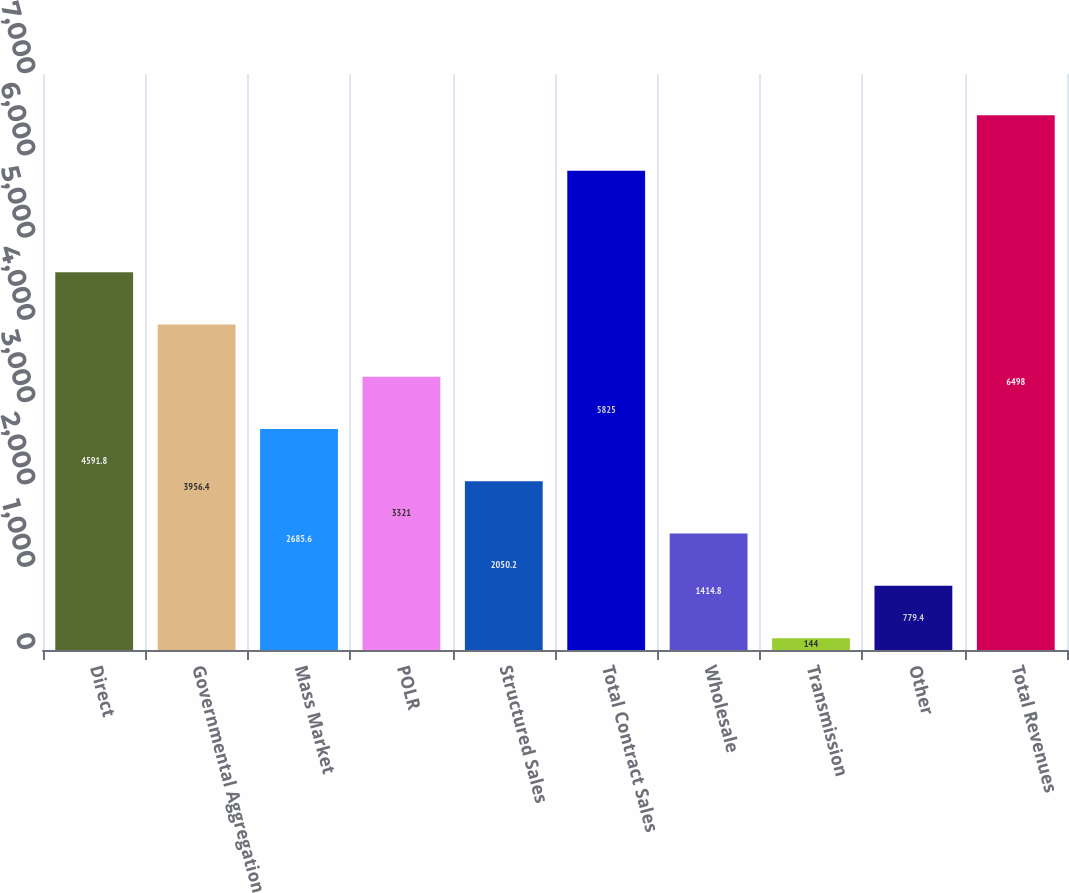Convert chart to OTSL. <chart><loc_0><loc_0><loc_500><loc_500><bar_chart><fcel>Direct<fcel>Governmental Aggregation<fcel>Mass Market<fcel>POLR<fcel>Structured Sales<fcel>Total Contract Sales<fcel>Wholesale<fcel>Transmission<fcel>Other<fcel>Total Revenues<nl><fcel>4591.8<fcel>3956.4<fcel>2685.6<fcel>3321<fcel>2050.2<fcel>5825<fcel>1414.8<fcel>144<fcel>779.4<fcel>6498<nl></chart> 